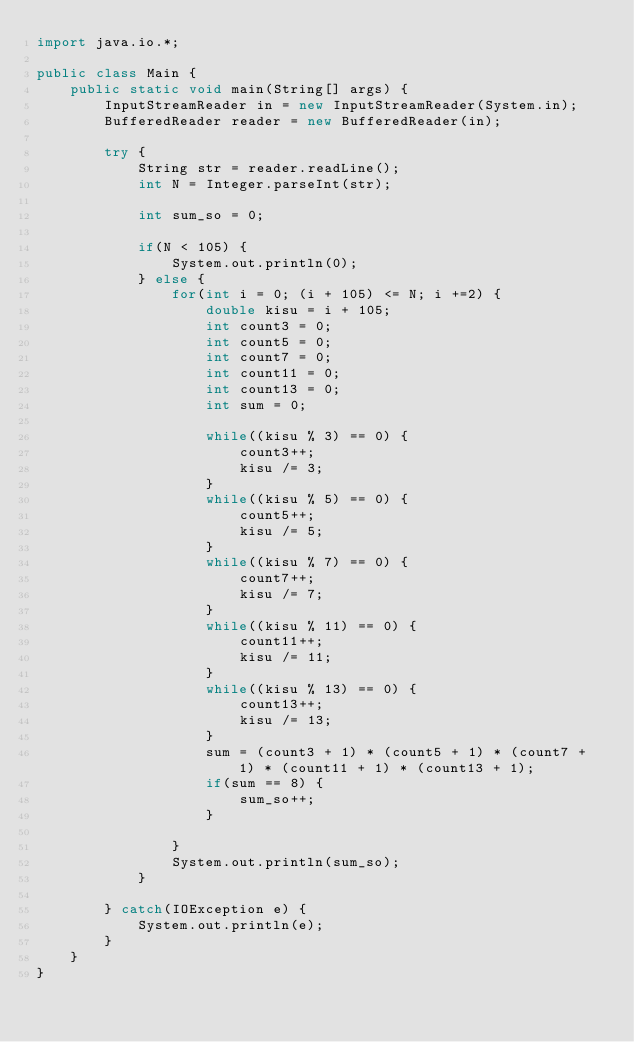<code> <loc_0><loc_0><loc_500><loc_500><_Java_>import java.io.*;

public class Main {
	public static void main(String[] args) {
		InputStreamReader in = new InputStreamReader(System.in);
		BufferedReader reader = new BufferedReader(in);
		
		try {
			String str = reader.readLine();
			int N = Integer.parseInt(str);
			
			int sum_so = 0;
			
			if(N < 105) {
				System.out.println(0);
			} else {
				for(int i = 0; (i + 105) <= N; i +=2) {
					double kisu = i + 105;
					int count3 = 0;
					int count5 = 0;
					int count7 = 0;
					int count11 = 0;
					int count13 = 0;
					int sum = 0;
					
					while((kisu % 3) == 0) {
						count3++;
						kisu /= 3;
					}
					while((kisu % 5) == 0) {
						count5++;
						kisu /= 5;
					}
					while((kisu % 7) == 0) {
						count7++;
						kisu /= 7;
					}
					while((kisu % 11) == 0) {
						count11++;
						kisu /= 11;
					}
					while((kisu % 13) == 0) {
						count13++;
						kisu /= 13;
					}
					sum = (count3 + 1) * (count5 + 1) * (count7 + 1) * (count11 + 1) * (count13 + 1);
					if(sum == 8) {
						sum_so++;
					}
					
				}
				System.out.println(sum_so);
			}
			
		} catch(IOException e) {
			System.out.println(e);
		}
	}
}
</code> 